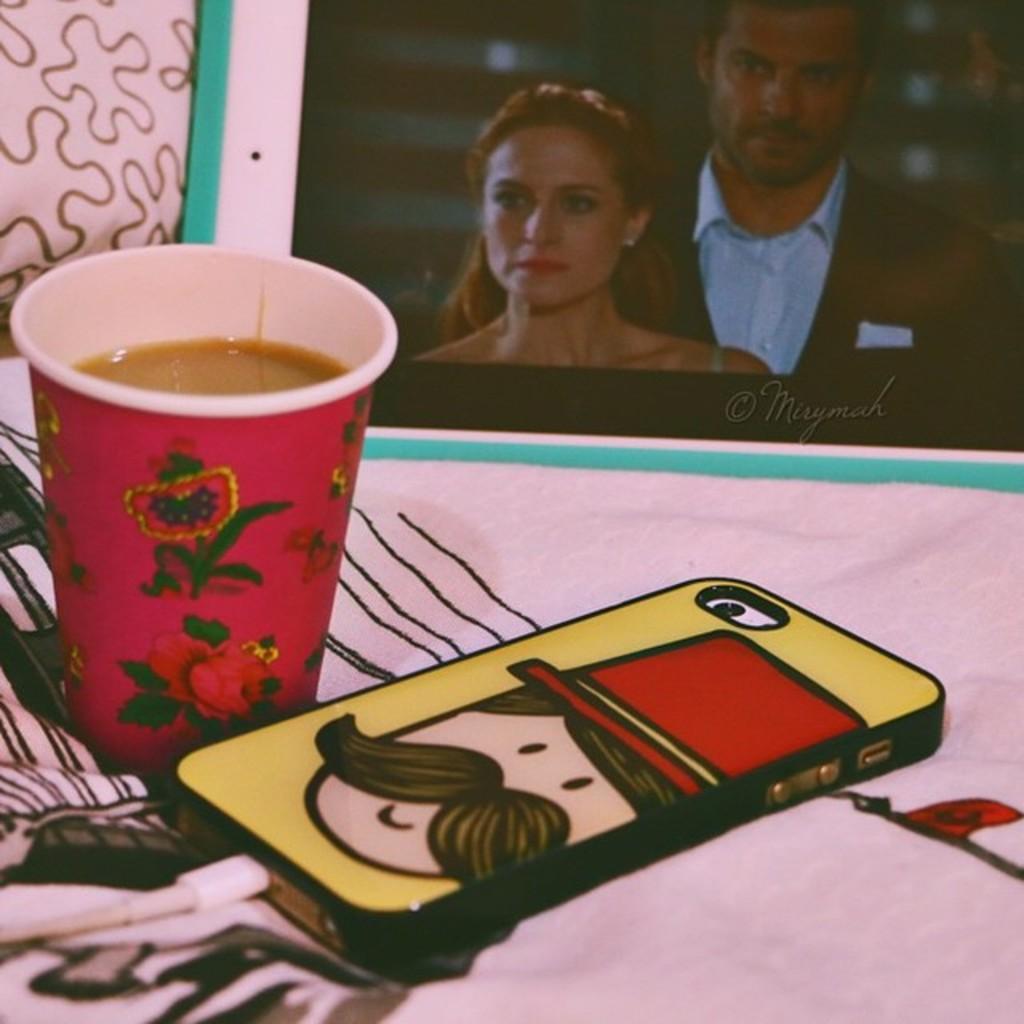Could you give a brief overview of what you see in this image? In this picture, it looks like a cloth and on the cloth there is a mobile, a cable, cup and a photo frame. On the photo frame it is written something. 